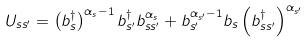Convert formula to latex. <formula><loc_0><loc_0><loc_500><loc_500>U _ { s s ^ { \prime } } = \left ( b _ { s } ^ { \dagger } \right ) ^ { \alpha _ { s } - 1 } b _ { s ^ { \prime } } ^ { \dagger } b _ { s s ^ { \prime } } ^ { \alpha _ { s } } + b _ { s ^ { \prime } } ^ { \alpha _ { s ^ { \prime } } - 1 } b _ { s } \left ( b _ { s s ^ { \prime } } ^ { \dagger } \right ) ^ { \alpha _ { s ^ { \prime } } }</formula> 